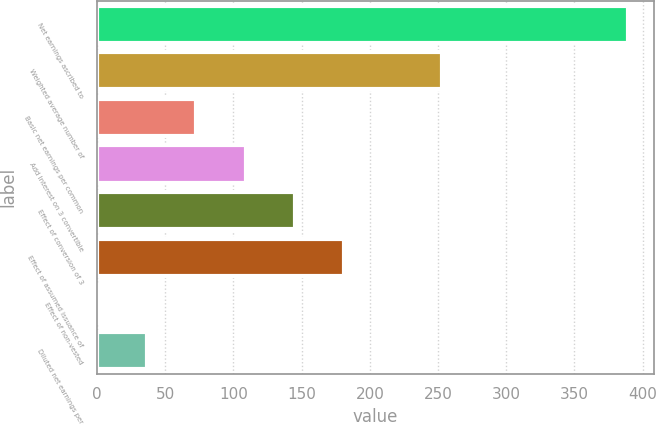Convert chart to OTSL. <chart><loc_0><loc_0><loc_500><loc_500><bar_chart><fcel>Net earnings ascribed to<fcel>Weighted average number of<fcel>Basic net earnings per common<fcel>Add Interest on 3 convertible<fcel>Effect of conversion of 3<fcel>Effect of assumed issuance of<fcel>Effect of non-vested<fcel>Diluted net earnings per<nl><fcel>389.01<fcel>252.87<fcel>72.82<fcel>108.83<fcel>144.84<fcel>180.85<fcel>0.8<fcel>36.81<nl></chart> 